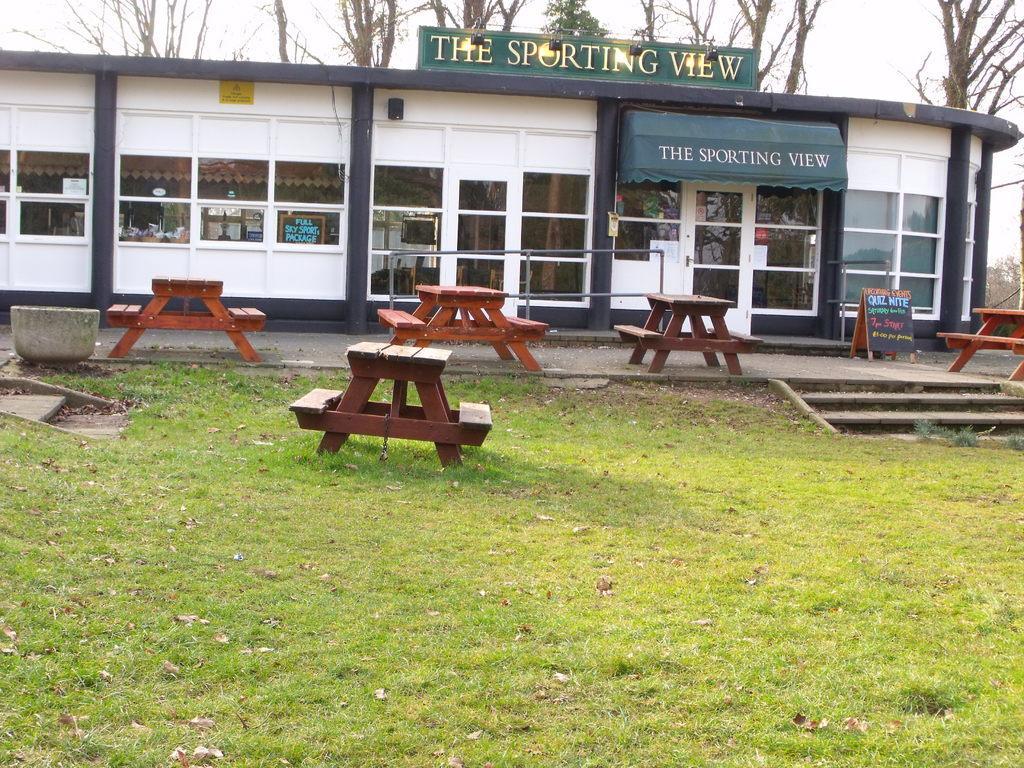In one or two sentences, can you explain what this image depicts? At the bottom of this image, there is grass on the ground. In the background, there are tables along with benches arranged, there is a building, which is having a hoarding, windows, a board, there are trees and there are clouds in the sky. 